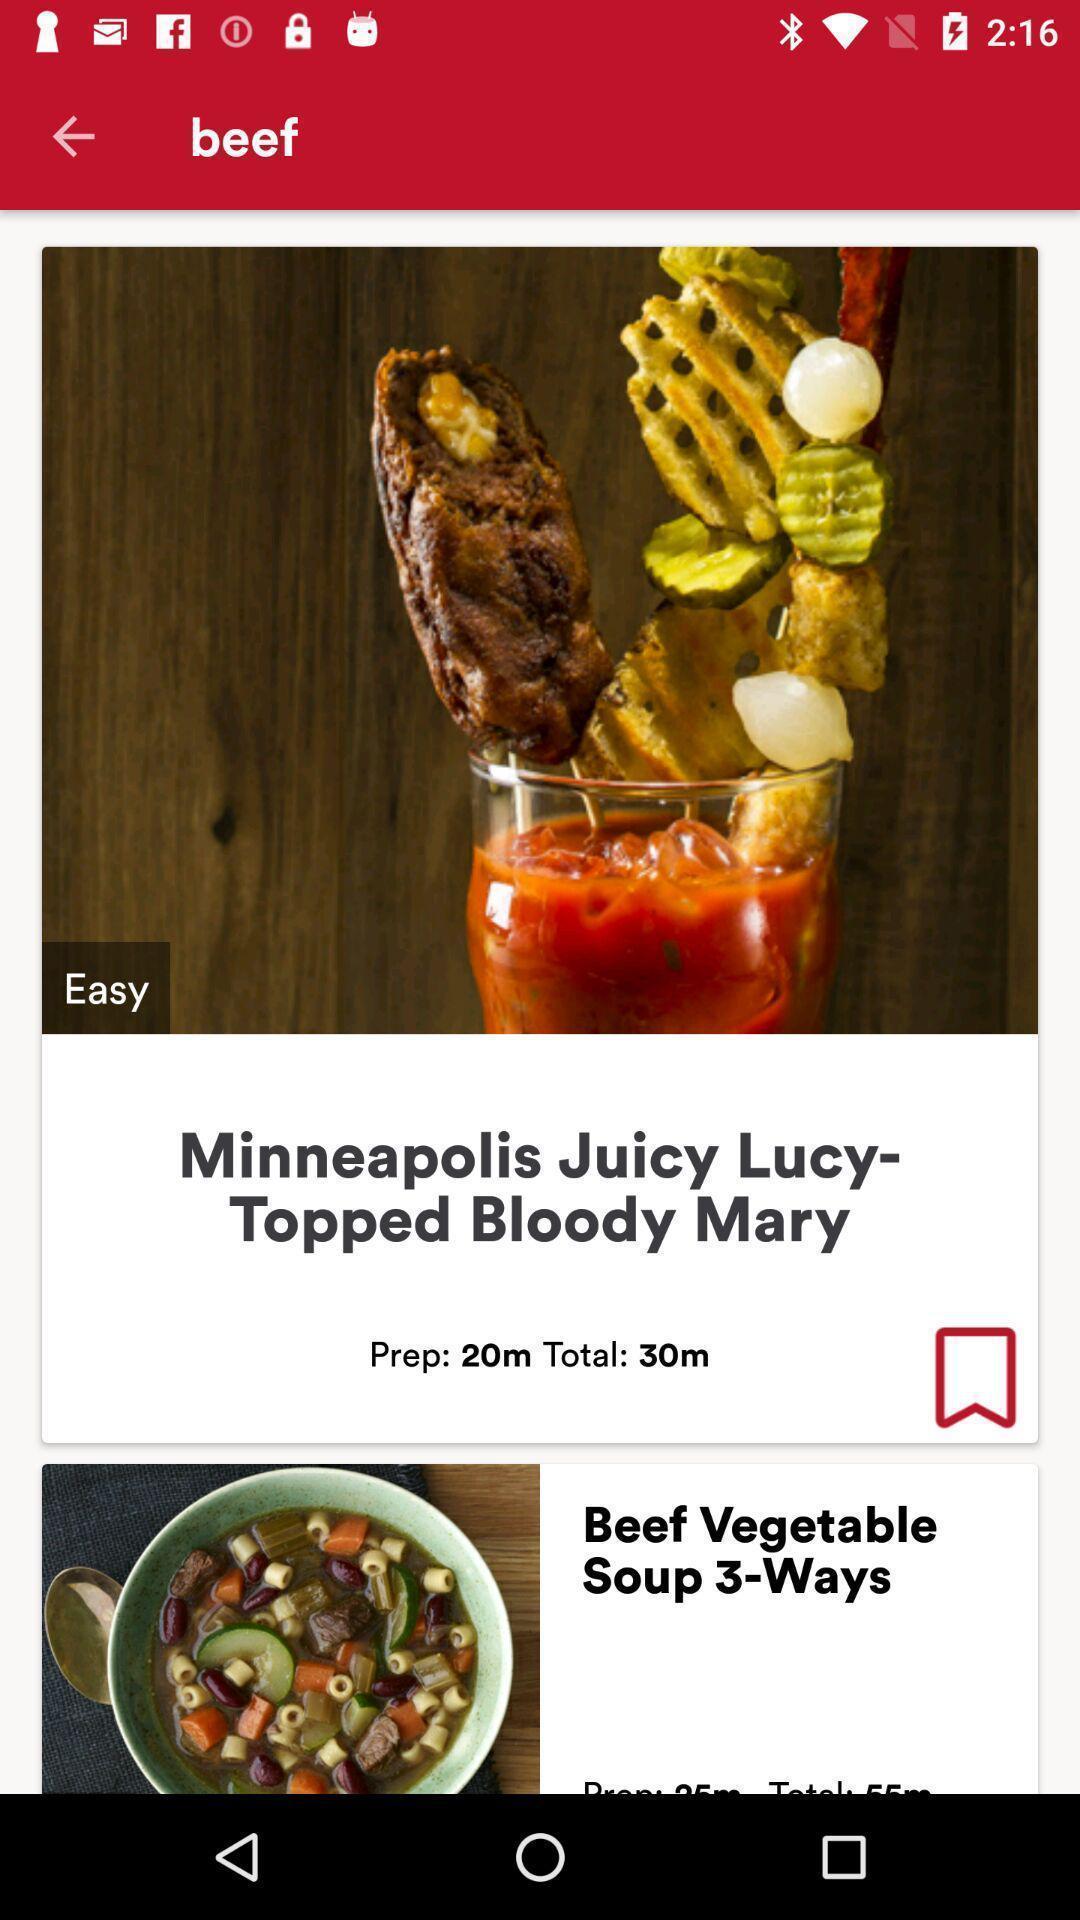What can you discern from this picture? Screen showing beef vegetable soup in a food app. 